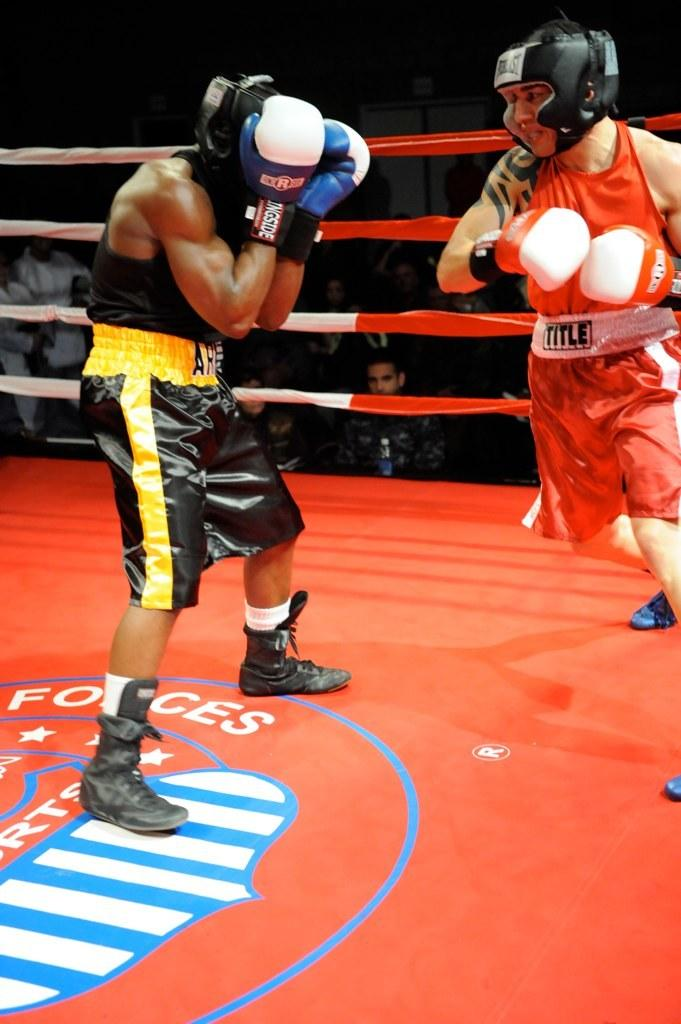<image>
Render a clear and concise summary of the photo. a couple boxers in a ring with one that has a shirt that says title 